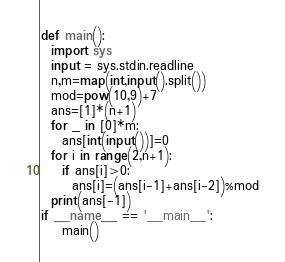<code> <loc_0><loc_0><loc_500><loc_500><_Python_>def main():
  import sys
  input = sys.stdin.readline
  n,m=map(int,input().split())
  mod=pow(10,9)+7
  ans=[1]*(n+1)
  for _ in [0]*m:
    ans[int(input())]=0
  for i in range(2,n+1):
    if ans[i]>0:
      ans[i]=(ans[i-1]+ans[i-2])%mod
  print(ans[-1])
if __name__ == '__main__':
    main()</code> 